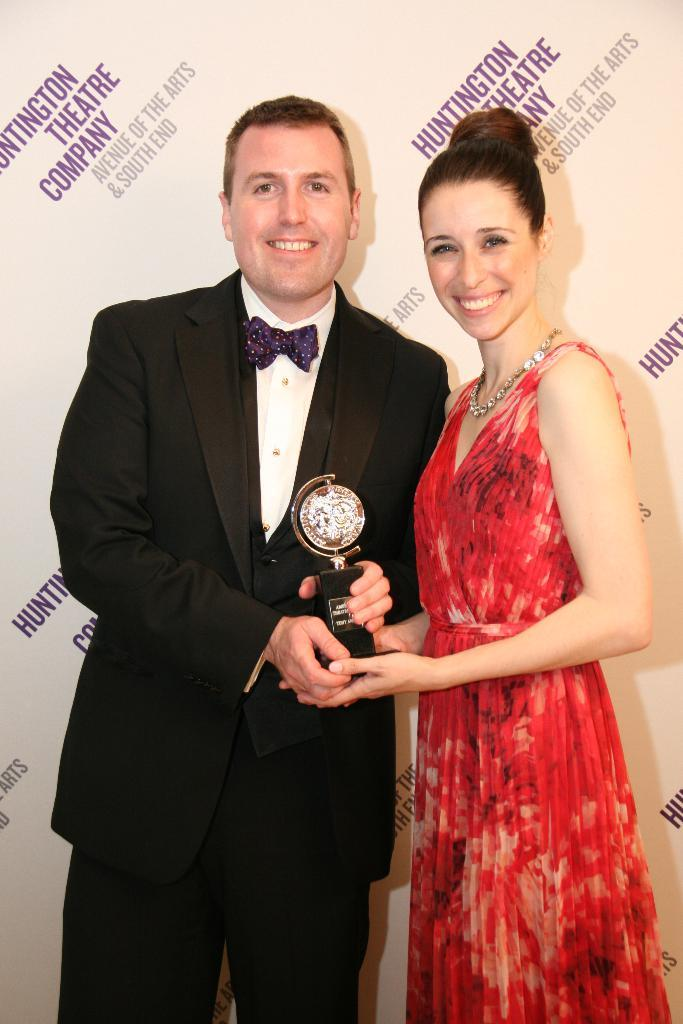<image>
Render a clear and concise summary of the photo. Two people in formal attire stand in front of a backdrop that says Huntington Theatre Company 